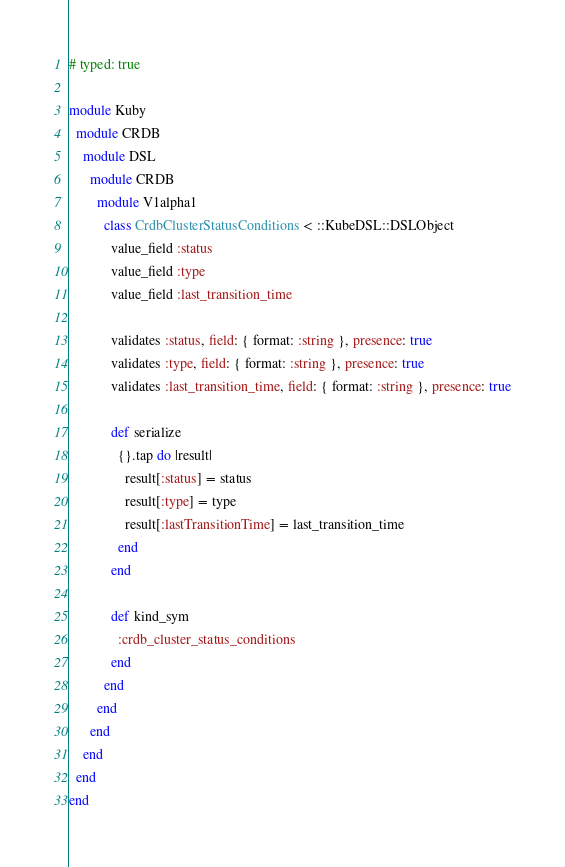Convert code to text. <code><loc_0><loc_0><loc_500><loc_500><_Ruby_># typed: true

module Kuby
  module CRDB
    module DSL
      module CRDB
        module V1alpha1
          class CrdbClusterStatusConditions < ::KubeDSL::DSLObject
            value_field :status
            value_field :type
            value_field :last_transition_time

            validates :status, field: { format: :string }, presence: true
            validates :type, field: { format: :string }, presence: true
            validates :last_transition_time, field: { format: :string }, presence: true

            def serialize
              {}.tap do |result|
                result[:status] = status
                result[:type] = type
                result[:lastTransitionTime] = last_transition_time
              end
            end

            def kind_sym
              :crdb_cluster_status_conditions
            end
          end
        end
      end
    end
  end
end</code> 